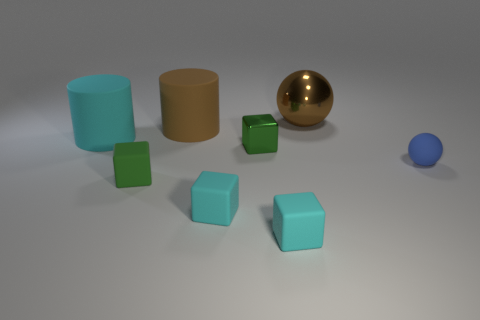Can you estimate the sizes of these objects relative to each other? Though it's difficult to determine the exact scale without a reference, we can estimate their sizes relatively. The cyan cubes are small and seem to be of uniform size. The green cubes are slightly larger. The brown cylinder has a comparable width to the larger green cube but is taller. The gold sphere appears to be larger than all the cubes and the blue sphere is the smallest object in the group. 